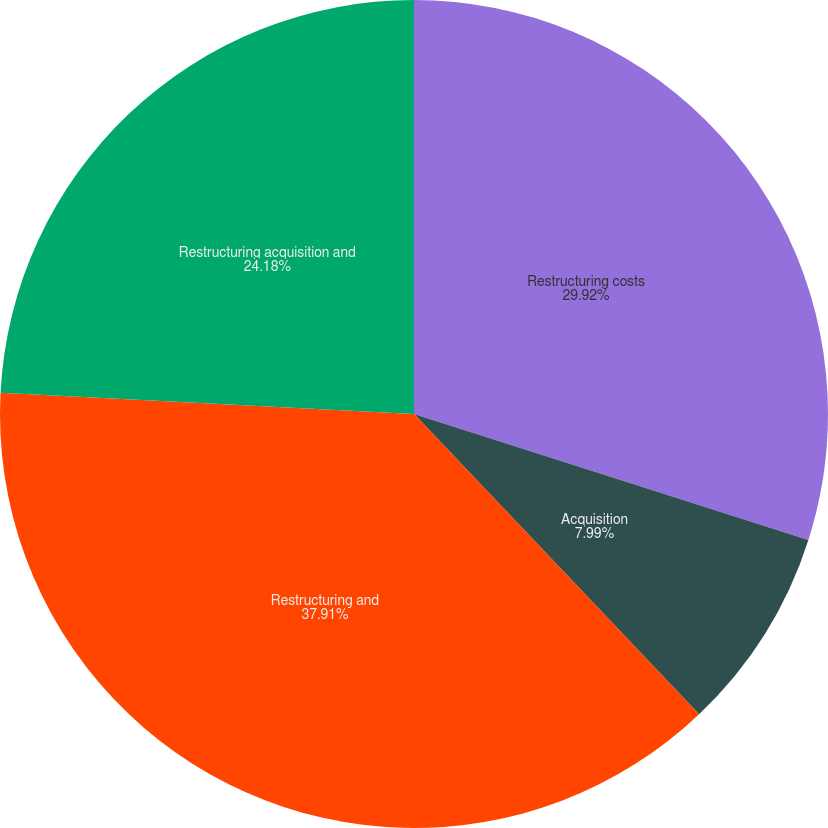Convert chart. <chart><loc_0><loc_0><loc_500><loc_500><pie_chart><fcel>Restructuring costs<fcel>Acquisition<fcel>Restructuring and<fcel>Restructuring acquisition and<nl><fcel>29.92%<fcel>7.99%<fcel>37.91%<fcel>24.18%<nl></chart> 